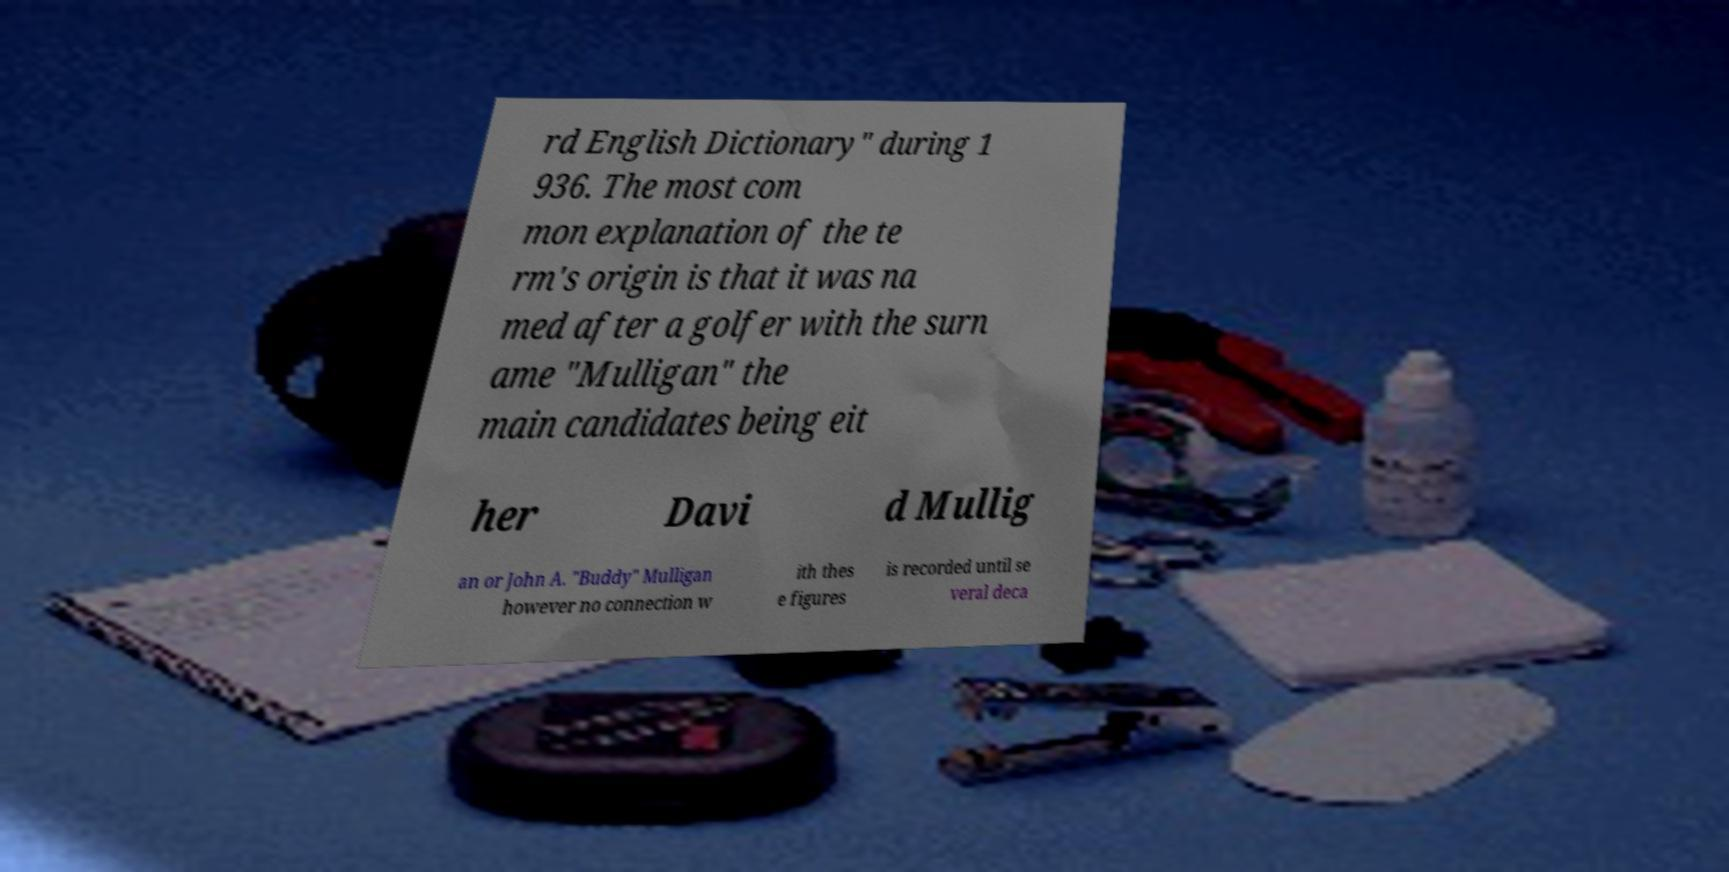Can you read and provide the text displayed in the image?This photo seems to have some interesting text. Can you extract and type it out for me? rd English Dictionary" during 1 936. The most com mon explanation of the te rm's origin is that it was na med after a golfer with the surn ame "Mulligan" the main candidates being eit her Davi d Mullig an or John A. "Buddy" Mulligan however no connection w ith thes e figures is recorded until se veral deca 